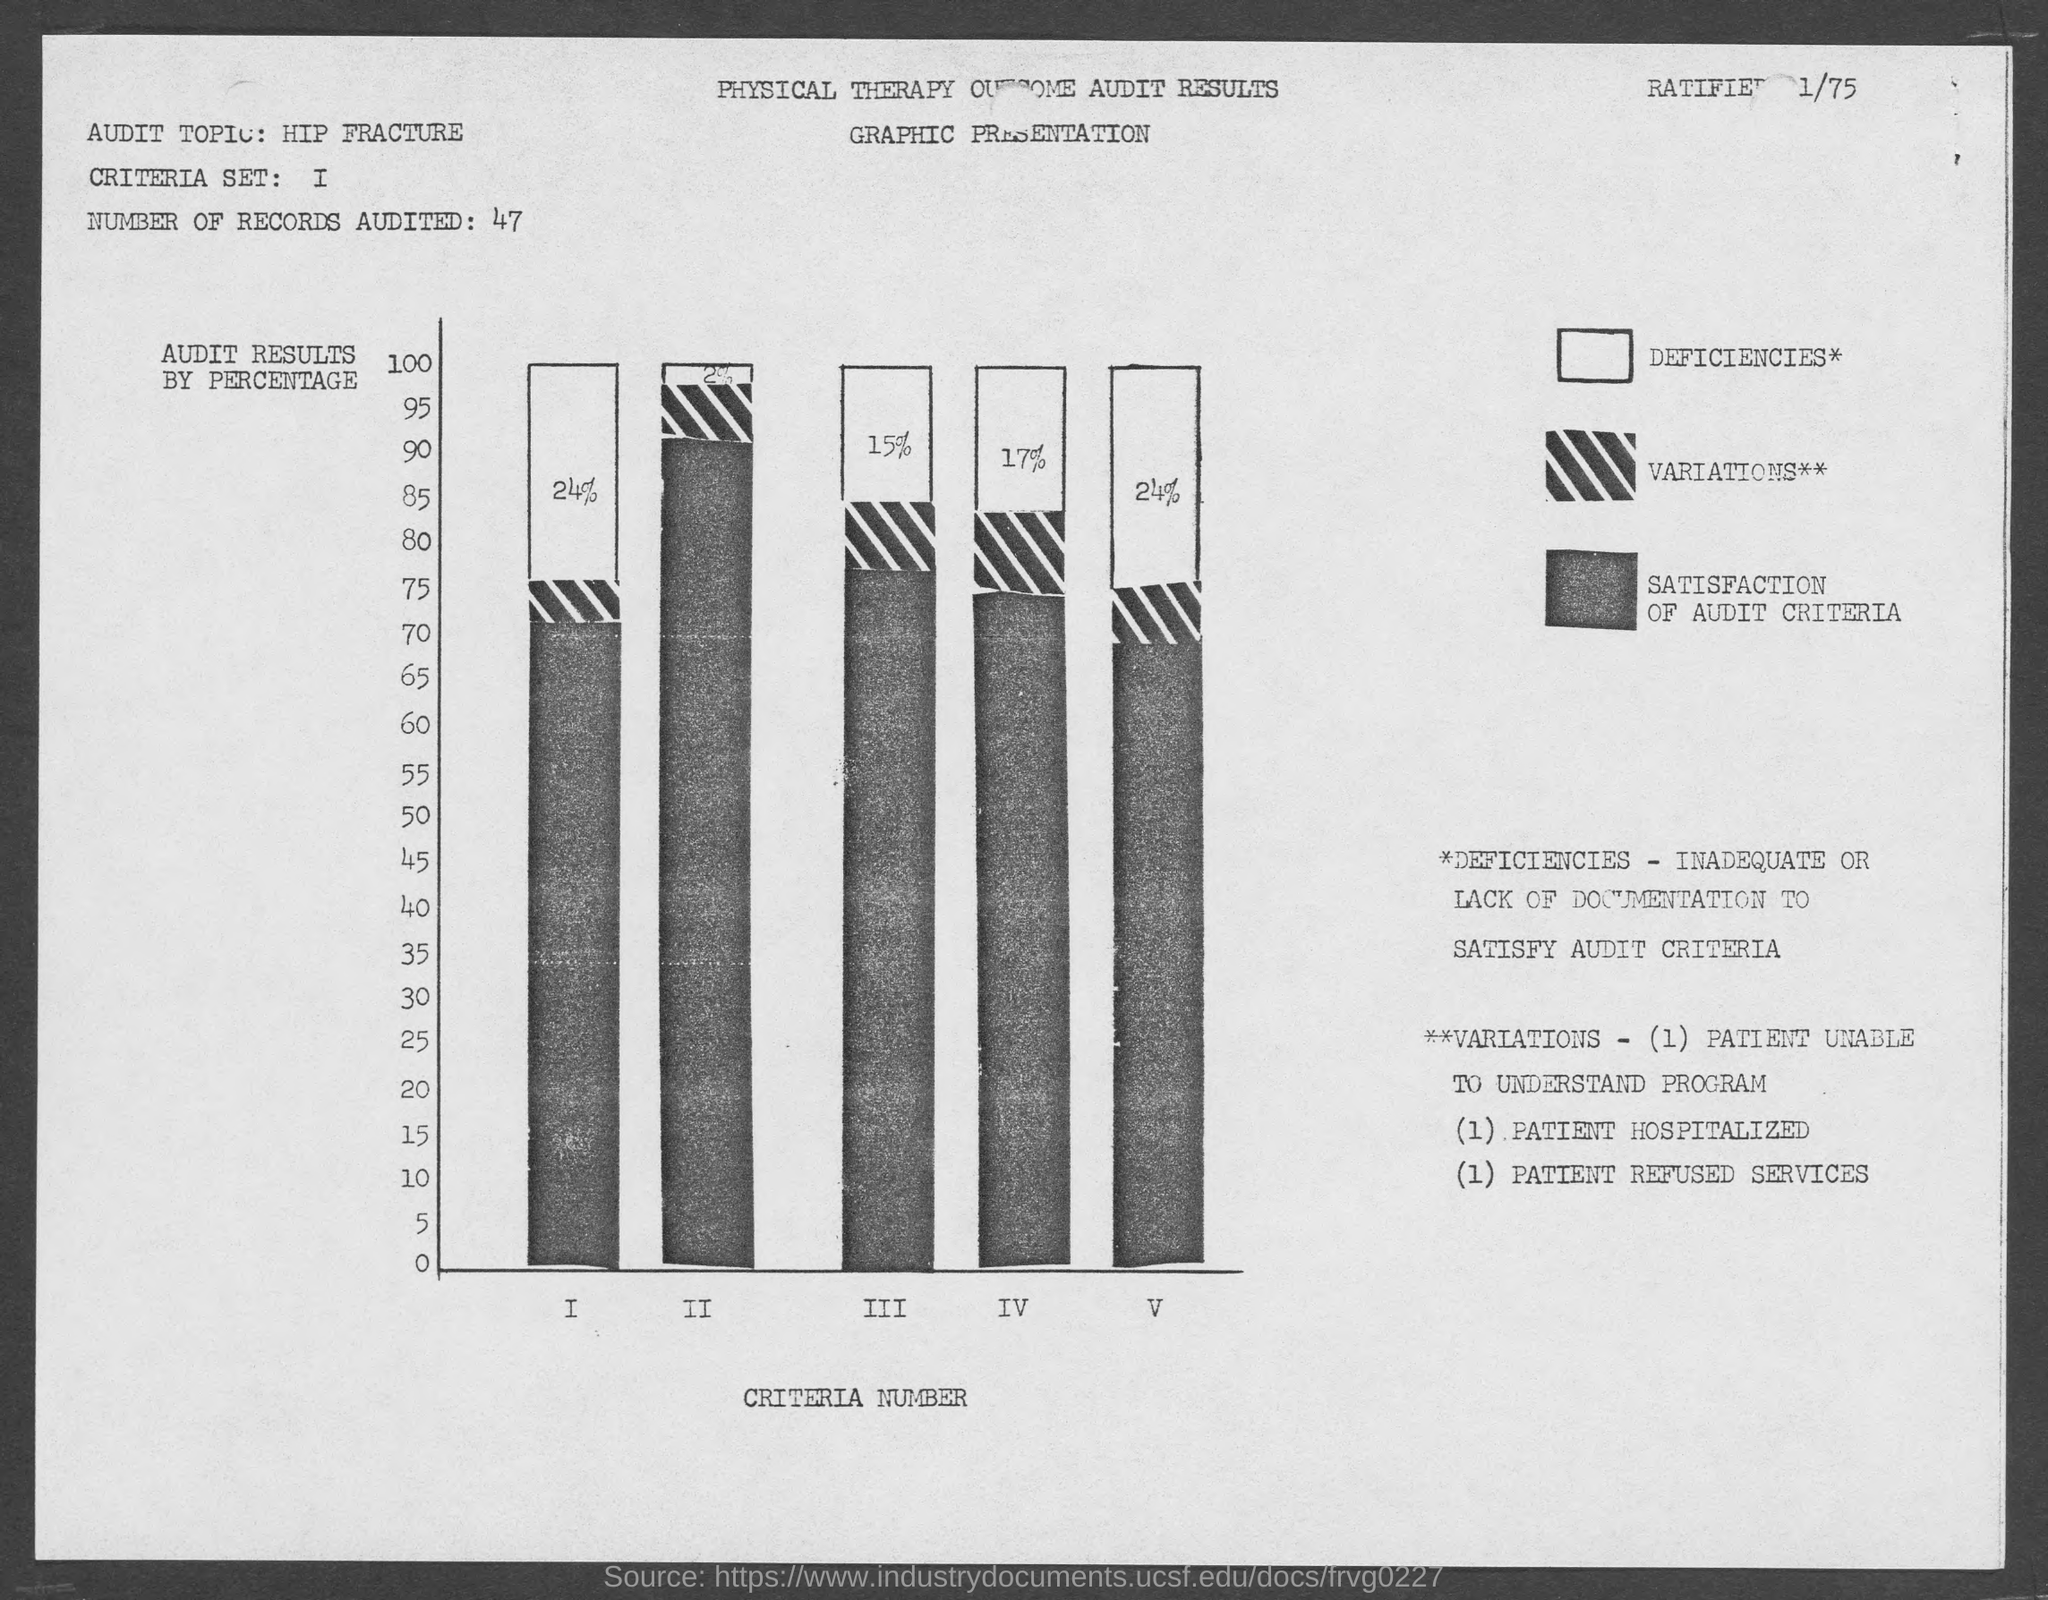How many records are audited?
Your response must be concise. 47. What is the audit topic?
Ensure brevity in your answer.  Hip Fracture. What represents x- axis of graph?
Your answer should be compact. Criteria Number. What represents y- axis of the graph?
Provide a succinct answer. Audit Results by Percentage. 